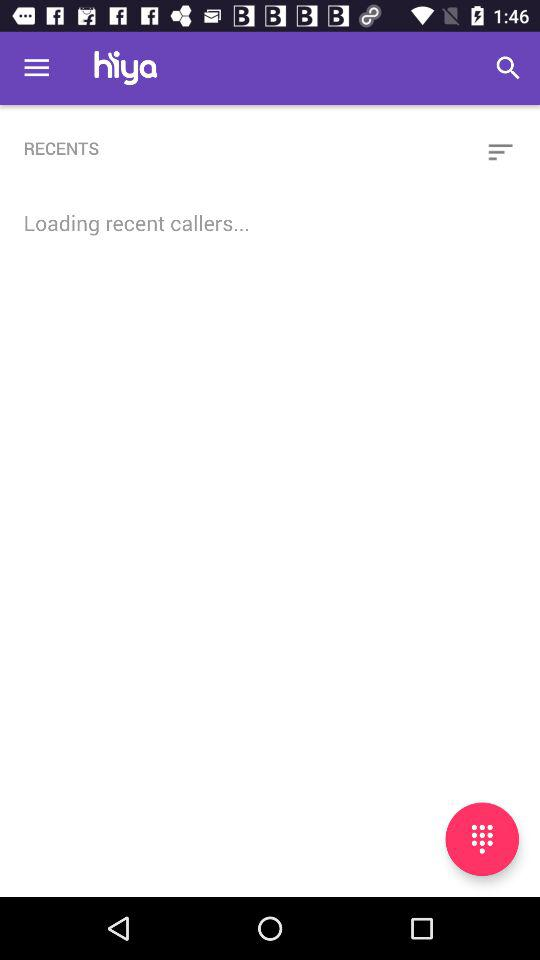What is the name of the company? The name of the company is "Hiya". 